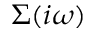Convert formula to latex. <formula><loc_0><loc_0><loc_500><loc_500>\Sigma ( i \omega )</formula> 